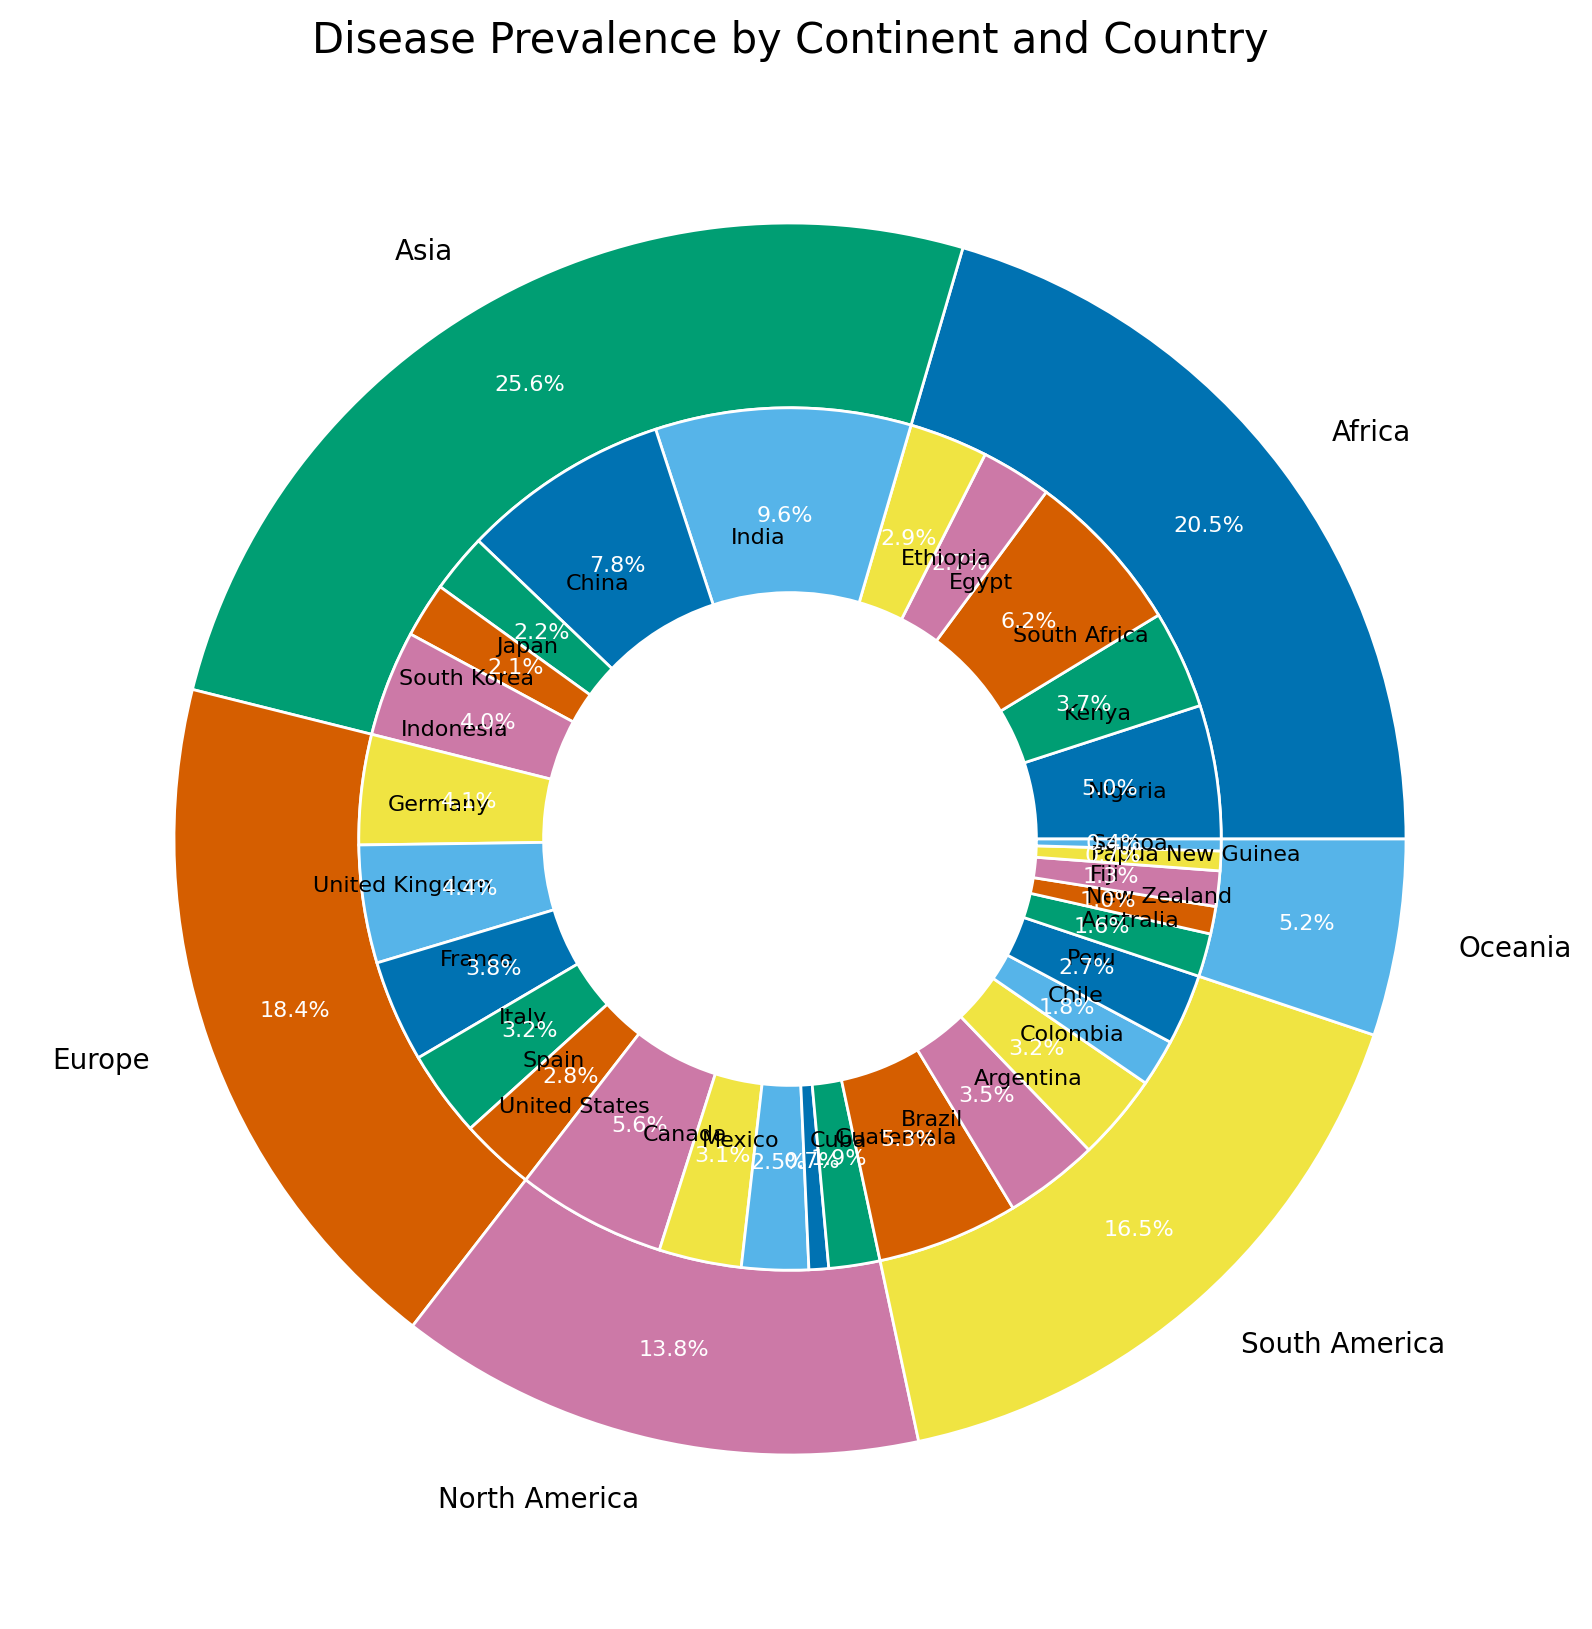What's the prevalence of the disease in North America compared to South America? To find the prevalence in North America, sum up the prevalence rates for the United States, Canada, Mexico, Cuba, and Guatemala. For South America, sum up the rates for Brazil, Argentina, Colombia, Chile, and Peru. 
North America's total: 0.0038 + 0.0021 + 0.0017 + 0.0005 + 0.0013 = 0.0094. 
South America's total: 0.0036 + 0.0024 + 0.0022 + 0.0012 + 0.0018 = 0.0112. 
North America's prevalence is less than South America's.
Answer: North America's prevalence is less than South America's Which continent has the highest total prevalence? Sum the prevalence of all the countries in each continent and then compare the totals. 
Africa: 0.0034 + 0.0025 + 0.0042 + 0.0018 + 0.0020 = 0.0139 
Asia: 0.0065 + 0.0053 + 0.0015 + 0.0014 + 0.0027 = 0.0174 
Europe: 0.0028 + 0.0030 + 0.0026 + 0.0022 + 0.0019 = 0.0125 
North America: 0.0038 + 0.0021 + 0.0017 + 0.0005 + 0.0013 = 0.0094 
South America: 0.0036 + 0.0024 + 0.0022 + 0.0012 + 0.0018 = 0.0112 
Oceania: 0.0011 + 0.0007 + 0.0009 + 0.0005 + 0.0003 = 0.0035 
Asia has the highest total prevalence.
Answer: Asia Which country shows the highest individual prevalence of the disease? Check the prevalence rates of all the countries and identify the highest value. 
India has a prevalence of 0.0065, which is the highest among all countries.
Answer: India In terms of percentage, how much more prevalent is the disease in Brazil compared to Germany? First, find the individual prevalence rates: Brazil: 0.0036, Germany: 0.0028. 
Then, compute the percentage increase: (0.0036 - 0.0028) / 0.0028 * 100 = 28.57%. 
The disease is approximately 28.57% more prevalent in Brazil than in Germany.
Answer: 28.57% What is the combined prevalence of the disease in all European countries? Sum the prevalence values for Germany, the United Kingdom, France, Italy, and Spain. 
0.0028 + 0.0030 + 0.0026 + 0.0022 + 0.0019 = 0.0125. 
The combined prevalence in all European countries is 0.0125.
Answer: 0.0125 Between Australia and New Zealand, which country has a lower prevalence? Compare the prevalence rates of Australia (0.0011) and New Zealand (0.0007). 
New Zealand has a lower prevalence.
Answer: New Zealand What is the average prevalence of the disease in African countries listed? Sum the prevalence values for Nigeria, Kenya, South Africa, Egypt, and Ethiopia, then divide by the number of countries. 
(0.0034 + 0.0025 + 0.0042 + 0.0018 + 0.0020) / 5 = 0.00318. 
The average prevalence in African countries listed is 0.00318.
Answer: 0.00318 